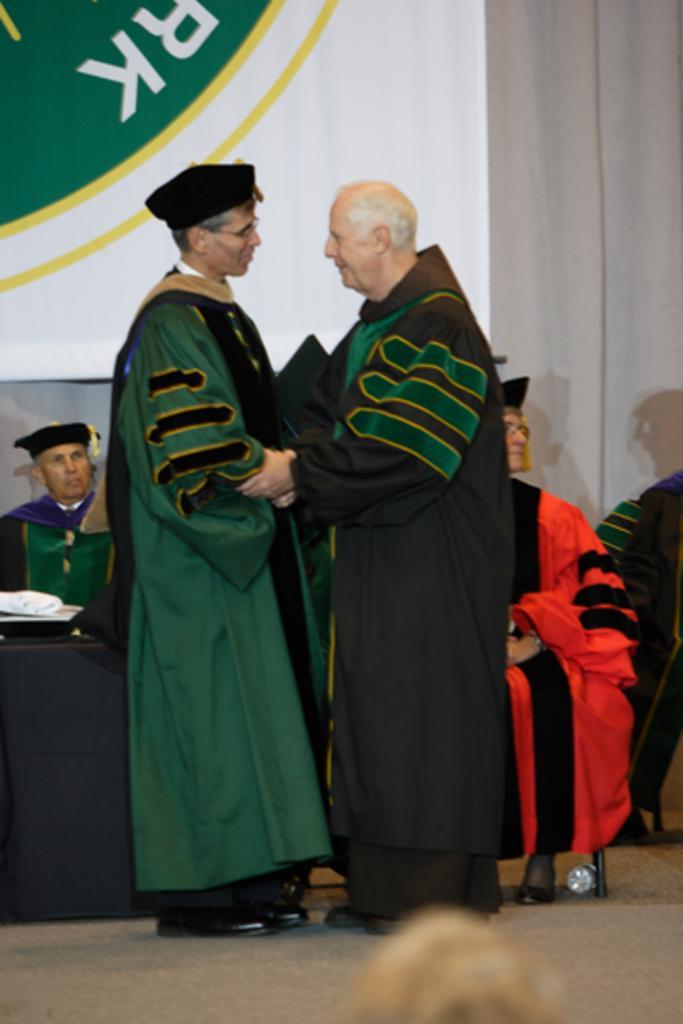Can you describe this image briefly? In the image there are two delegates greeting each other and behind them there are few people sitting on the chair. 